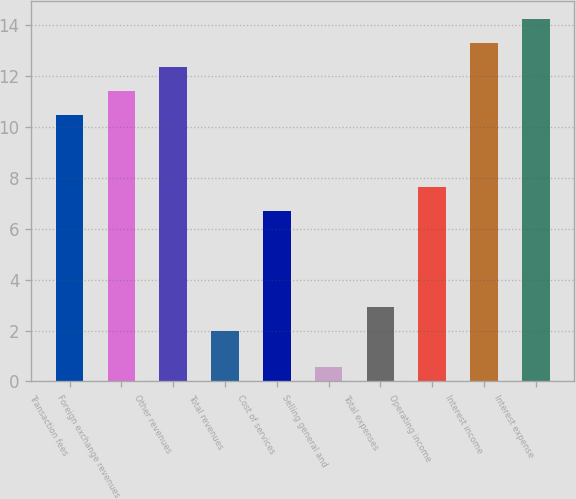Convert chart. <chart><loc_0><loc_0><loc_500><loc_500><bar_chart><fcel>Transaction fees<fcel>Foreign exchange revenues<fcel>Other revenues<fcel>Total revenues<fcel>Cost of services<fcel>Selling general and<fcel>Total expenses<fcel>Operating income<fcel>Interest income<fcel>Interest expense<nl><fcel>10.46<fcel>11.4<fcel>12.34<fcel>2<fcel>6.7<fcel>0.56<fcel>2.94<fcel>7.64<fcel>13.28<fcel>14.22<nl></chart> 